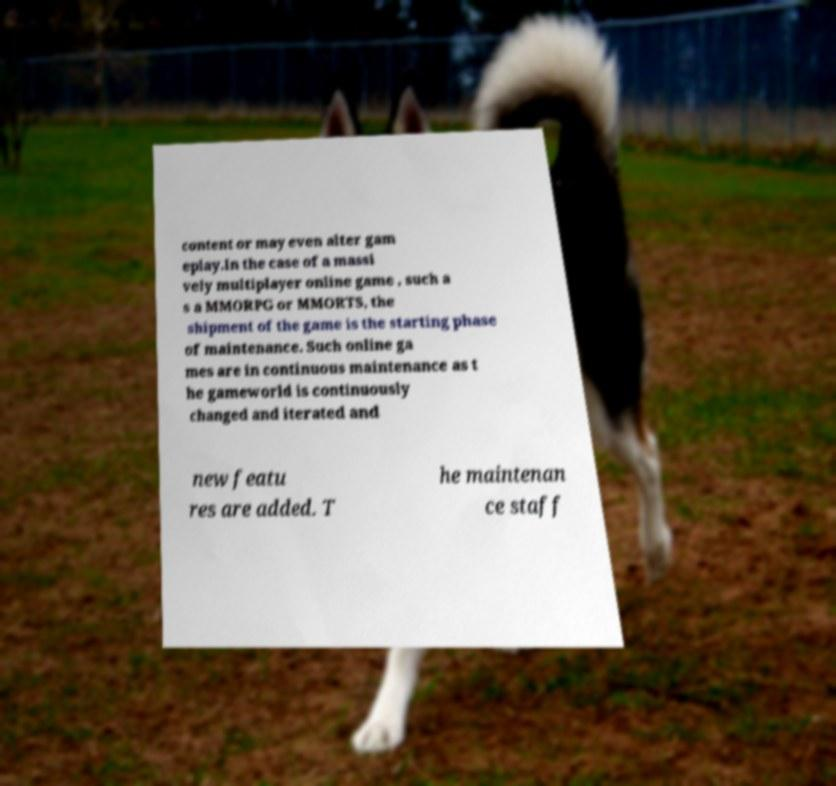I need the written content from this picture converted into text. Can you do that? content or may even alter gam eplay.In the case of a massi vely multiplayer online game , such a s a MMORPG or MMORTS, the shipment of the game is the starting phase of maintenance. Such online ga mes are in continuous maintenance as t he gameworld is continuously changed and iterated and new featu res are added. T he maintenan ce staff 